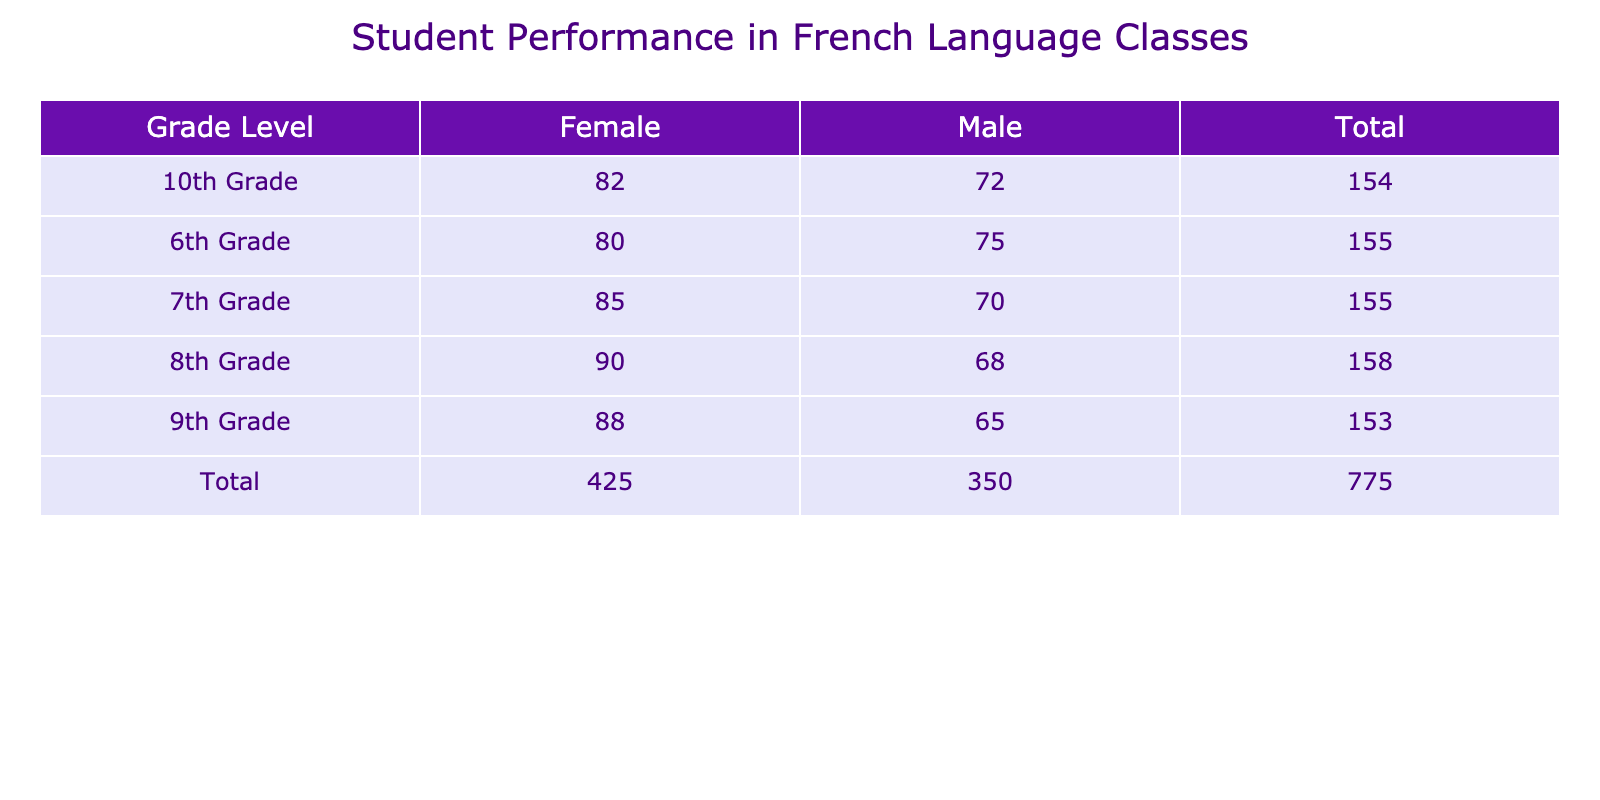What is the average score of Male students in 8th Grade? The table shows that the average score for Male students in 8th Grade is 68.
Answer: 68 What is the total average score of Female students across all grades? To find the total average score for Female students, simply add the average scores: 80 (6th Grade) + 85 (7th Grade) + 90 (8th Grade) + 88 (9th Grade) + 82 (10th Grade) = 425.
Answer: 425 Is the average score of Male students higher in 10th Grade compared to 9th Grade? The average score for Male students in 10th Grade is 72 and in 9th Grade is 65. Since 72 is higher than 65, the statement is true.
Answer: Yes What is the difference in average scores between Female and Male students in 7th Grade? The average score for Female students in 7th Grade is 85 and for Male students it is 70. The difference is 85 - 70 = 15.
Answer: 15 Which grade level has the highest average score for Female students? Looking at the average scores for Female students, 90 in 8th Grade is the highest among all grade levels.
Answer: 8th Grade What is the average score of Male students in 6th and 9th Grades combined? To find the average score, first sum the average scores: 75 (6th Grade) + 65 (9th Grade) = 140. Then, divide by the number of grades (2): 140 / 2 = 70.
Answer: 70 Do Male students perform better than Female students in 6th Grade? The average score for Male students in 6th Grade is 75, while for Female students it is 80. Since 75 is less than 80, the statement is false.
Answer: No How many students are there in total across all grade levels for Female students? The total number of Female students is the sum of all Female students across grades: 20 (6th Grade) + 28 (7th Grade) + 24 (8th Grade) + 21 (9th Grade) + 23 (10th Grade) = 116.
Answer: 116 Which gender has a higher total average score over all grade levels? To find the total average scores, for Males: 75 + 70 + 68 + 65 + 72 = 350; for Females: 80 + 85 + 90 + 88 + 82 = 425. Since 425 is greater than 350, Females have a higher total average score.
Answer: Females 